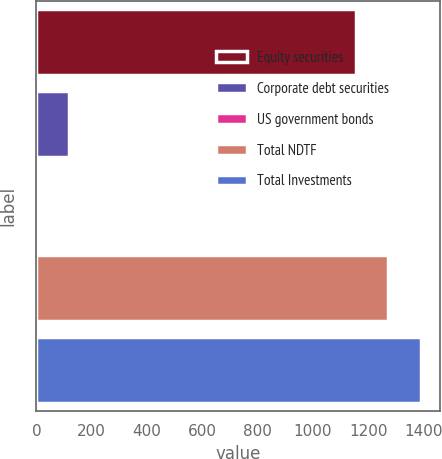Convert chart to OTSL. <chart><loc_0><loc_0><loc_500><loc_500><bar_chart><fcel>Equity securities<fcel>Corporate debt securities<fcel>US government bonds<fcel>Total NDTF<fcel>Total Investments<nl><fcel>1157<fcel>118.3<fcel>2<fcel>1273.3<fcel>1389.6<nl></chart> 